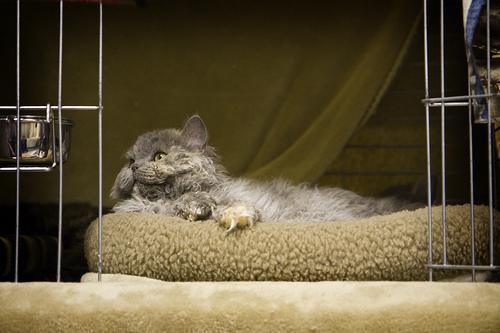What type of animal is in this cage?
From the following set of four choices, select the accurate answer to respond to the question.
Options: Reptile, domestic, flying, wild. Domestic. 